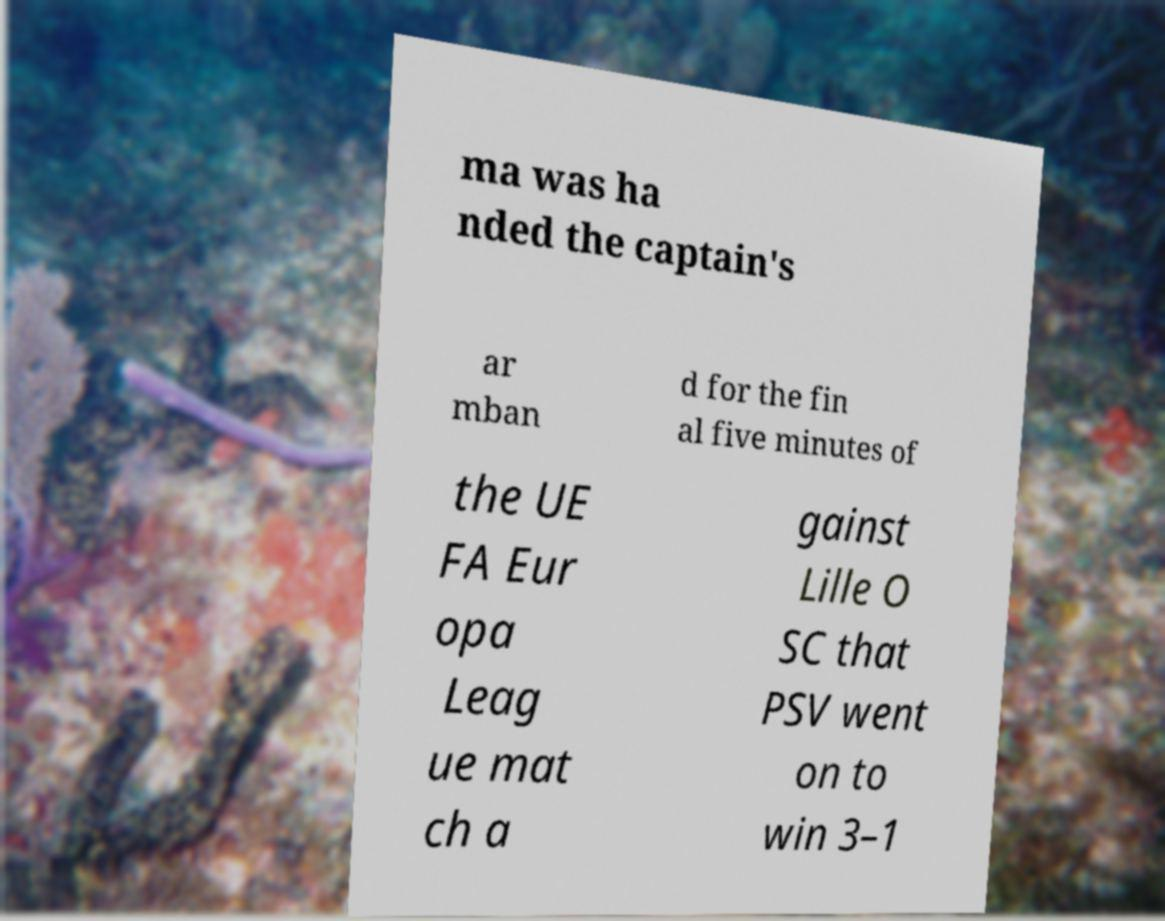What messages or text are displayed in this image? I need them in a readable, typed format. ma was ha nded the captain's ar mban d for the fin al five minutes of the UE FA Eur opa Leag ue mat ch a gainst Lille O SC that PSV went on to win 3–1 